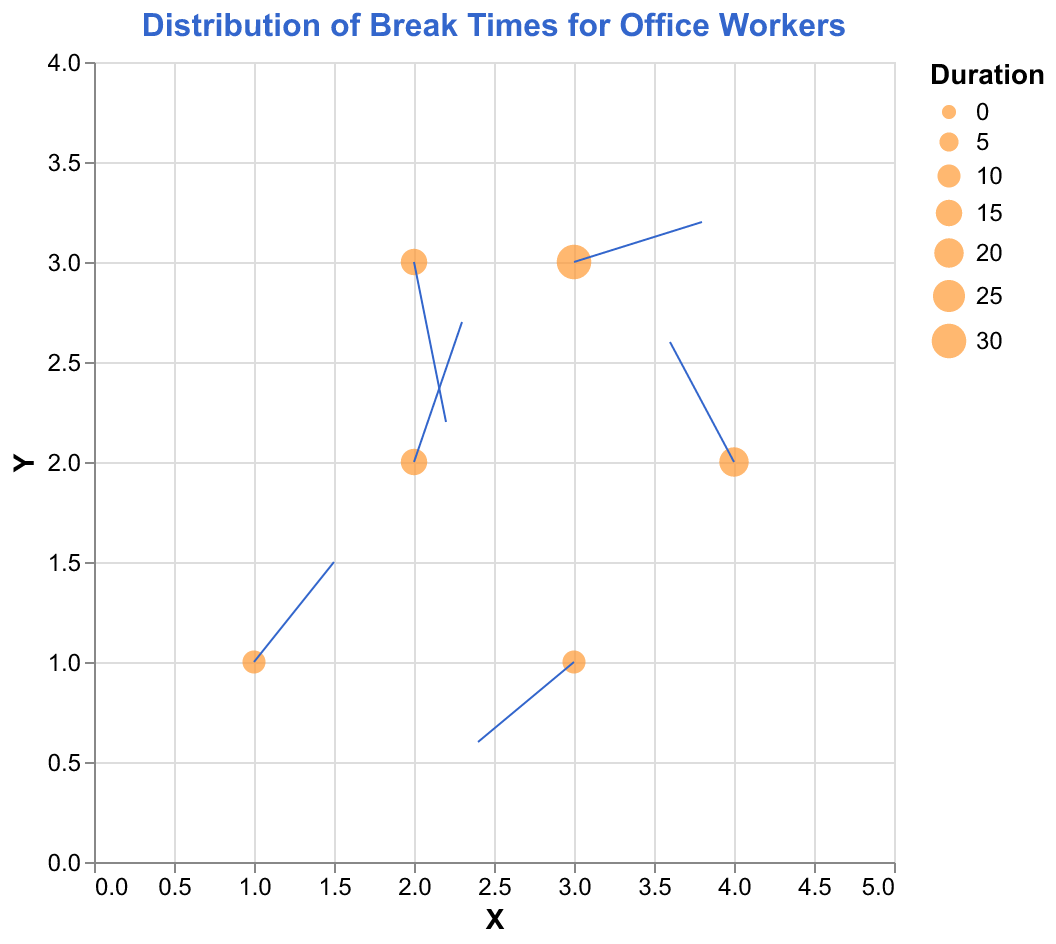How many break data points are represented in the plot? There are six unique time points and corresponding coordinates that represent breaks, specifically at 9:00, 10:30, 12:00, 13:30, 15:00, and 16:30. Each point corresponds to a different data entry with arrow vectors (U, V).
Answer: 6 What is the title of the plot? The title is displayed at the top of the plot and reads "Distribution of Break Times for Office Workers".
Answer: Distribution of Break Times for Office Workers Which break occurs at 12:00, and how long does it last? At 12:00, the break data point is at coordinates (3, 3) with an arrow vector (0.8, 0.2), and the tooltip indicates that the break lasts for 30 minutes.
Answer: 30 minutes What are the directions and magnitudes of the arrows in the plot? The figure indicates the direction and length of each break duration by the vectors (U, V) for each break point. For example, at 9:00, the vector (0.5, 0.5) signifies a direction, and its magnitude is calculated by sqrt(0.5^2 + 0.5^2) = sqrt(0.5), approximately 0.7. Other vectors can be similarly calculated.
Answer: Magnitudes vary Which break has the longest duration and where is it located on the plot? By looking at the sizes of the points and the tooltip information, the break lasting 30 minutes, which is the longest, occurs at coordinates (3, 3).
Answer: 3, 3 What is the average duration of the breaks displayed? Summing the individual durations: 10 + 15 + 30 + 20 + 10 + 15 = 100 minutes. Dividing by the number of breaks (6): 100 / 6 = approximately 16.67 minutes.
Answer: 16.67 minutes Compare the break direction at 10:30 and 16:30. Which one moves more vertically? At 10:30, the vector (0.3, 0.7) indicates more vertical movement compared to (0.2, -0.8) at 16:30. The magnitude of the vertical component (V) at 10:30 (0.7) is compared to that at 16:30 (0.8), both needing absolute values. By comparison, 0.8 is greater than 0.7.
Answer: 16:30 What is the direction of the break at 15:00, and what does it indicate about the movement pattern? The vector at 15:00 is (-0.6, -0.4), indicating movement to the left and downward direction from its point (3, 1). The direction suggests a break pattern away from central activity points.
Answer: Left and downward How many breaks point to the left direction? Which points are they? To count vectors with negative U values (-0.4 at 13:30 and -0.6 at 15:00) shows leftward direction. The specific points are (4, 2) and (3, 1).
Answer: 2 points (13:30, 15:00) Which break has a downward trend greater than its upward trend? Compare the U and V components that are negative for downward trends. 16:30's (0.2, -0.8) has a downward (-0.8) greater than upward trends noted for magnitude comparison to others.
Answer: 16:30 